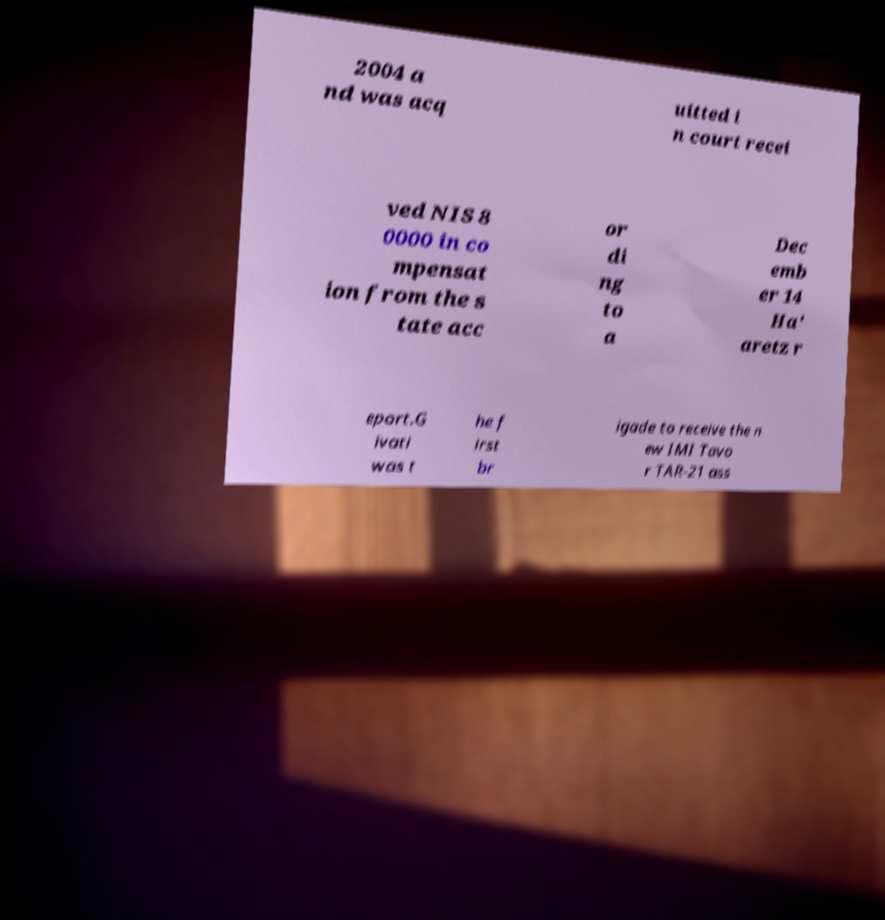What messages or text are displayed in this image? I need them in a readable, typed format. 2004 a nd was acq uitted i n court recei ved NIS 8 0000 in co mpensat ion from the s tate acc or di ng to a Dec emb er 14 Ha' aretz r eport.G ivati was t he f irst br igade to receive the n ew IMI Tavo r TAR-21 ass 